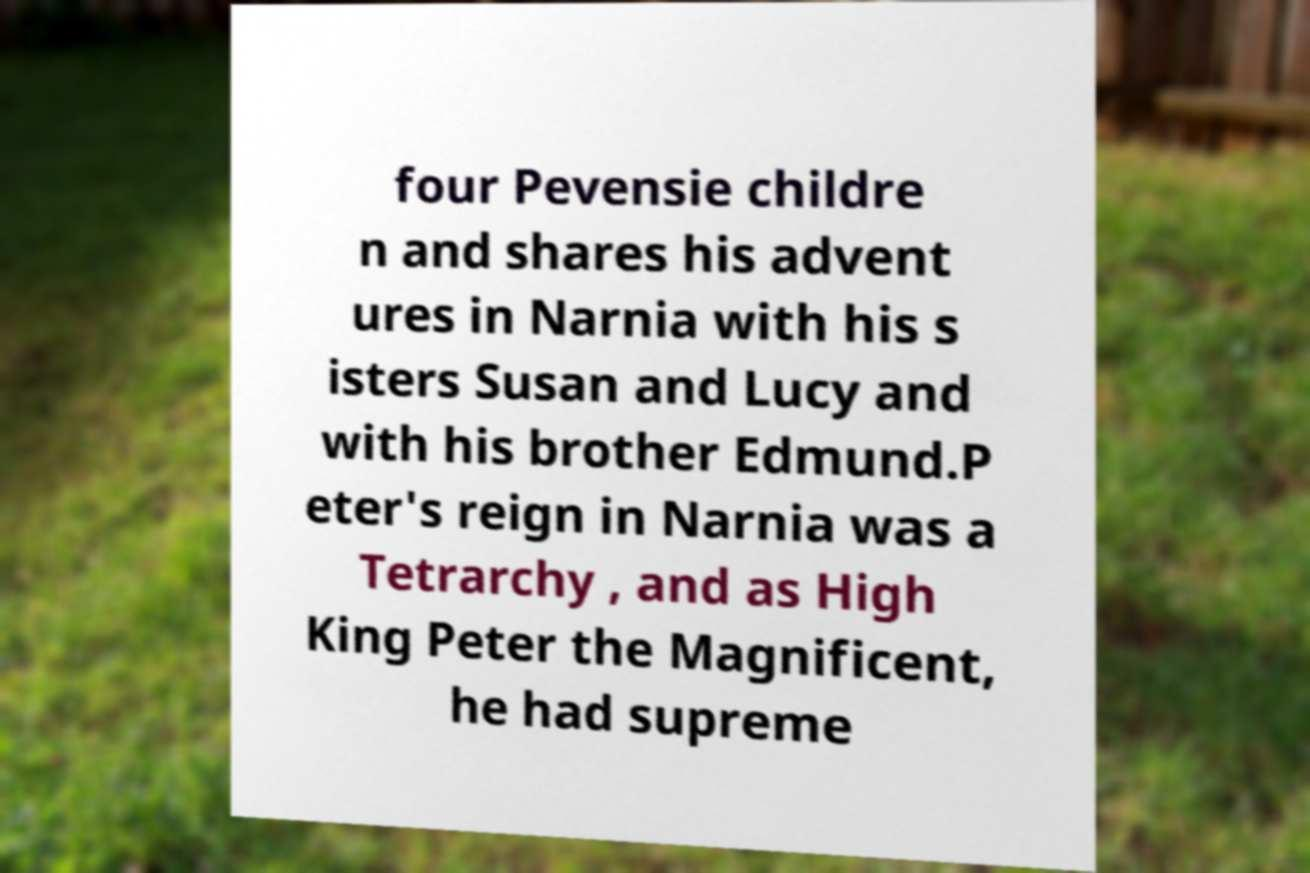Can you accurately transcribe the text from the provided image for me? four Pevensie childre n and shares his advent ures in Narnia with his s isters Susan and Lucy and with his brother Edmund.P eter's reign in Narnia was a Tetrarchy , and as High King Peter the Magnificent, he had supreme 